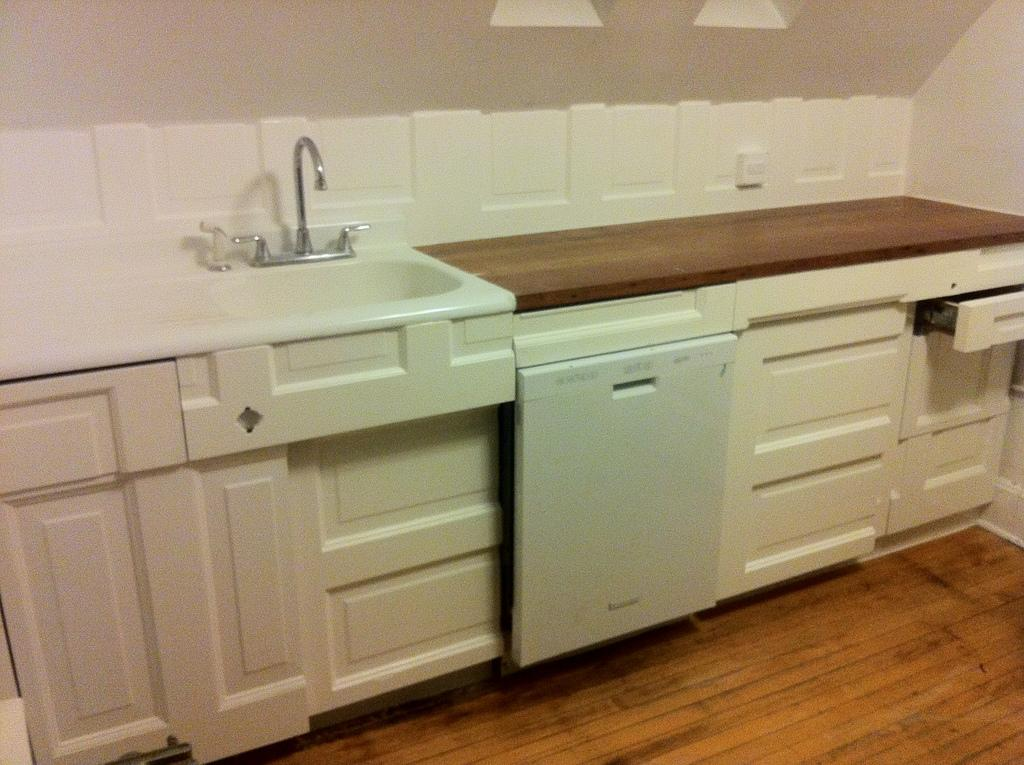What is placed on the floor in the image? There is a table on the floor in the image. What type of appliance can be seen in the image? There is a dishwasher in the image. What is visible on one side of the image? There is a wall visible in the image. Can you tell me what time the clock on the wall is showing in the image? There is no clock present in the image. What type of wilderness animals can be seen in the image? There are no wilderness animals present in the image. 